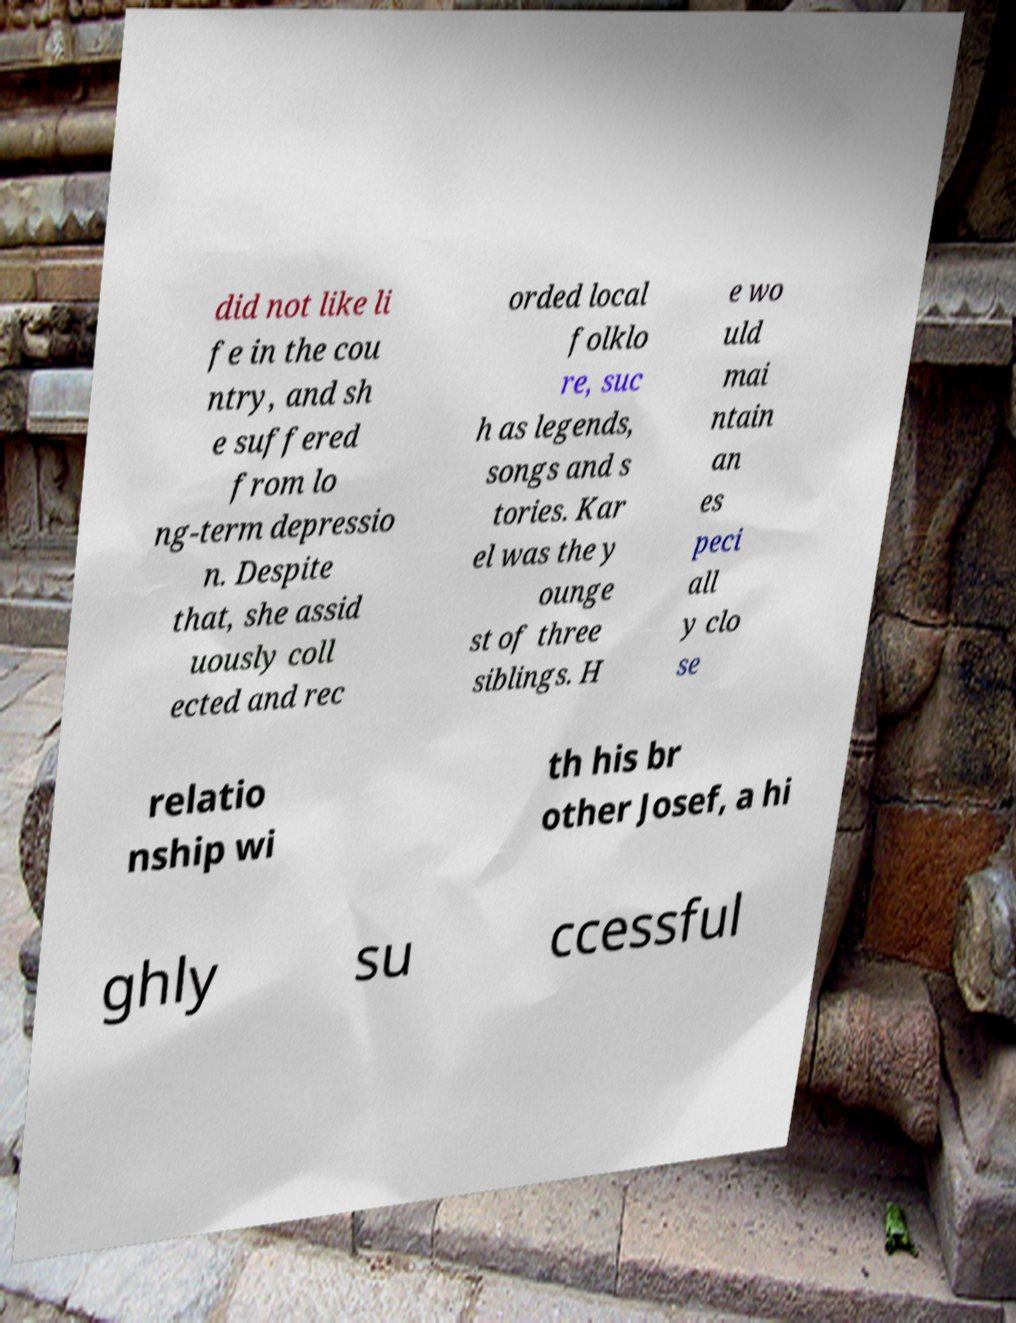I need the written content from this picture converted into text. Can you do that? did not like li fe in the cou ntry, and sh e suffered from lo ng-term depressio n. Despite that, she assid uously coll ected and rec orded local folklo re, suc h as legends, songs and s tories. Kar el was the y ounge st of three siblings. H e wo uld mai ntain an es peci all y clo se relatio nship wi th his br other Josef, a hi ghly su ccessful 